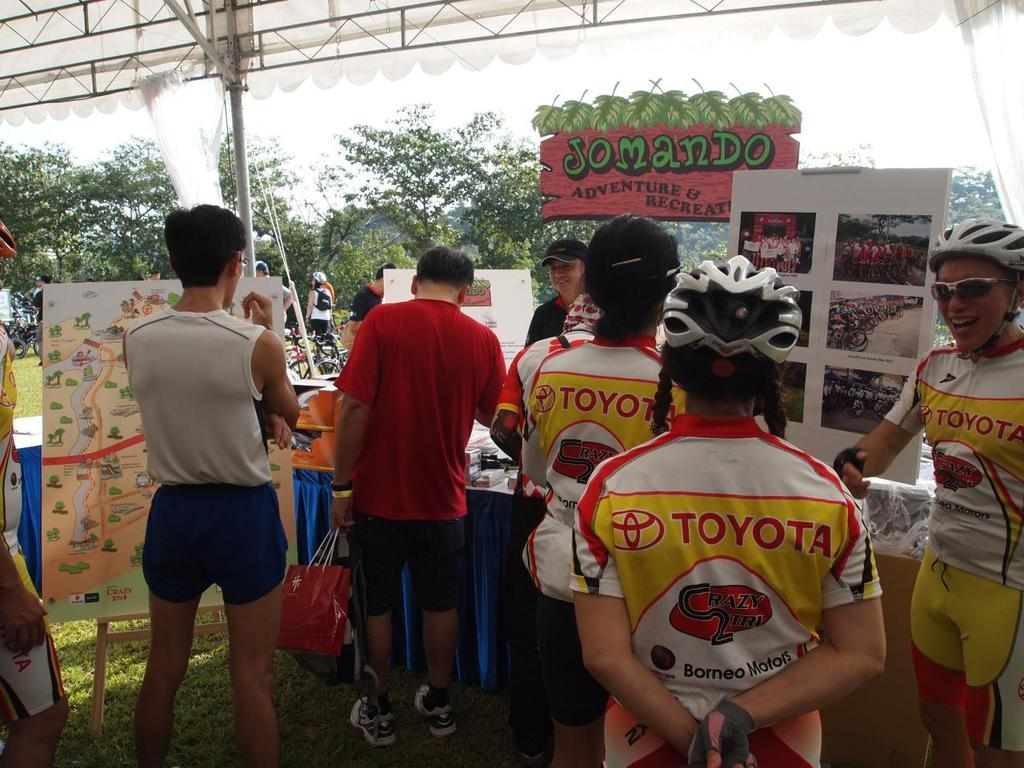<image>
Create a compact narrative representing the image presented. The cyclists have a Toyota ad on their uniforms 